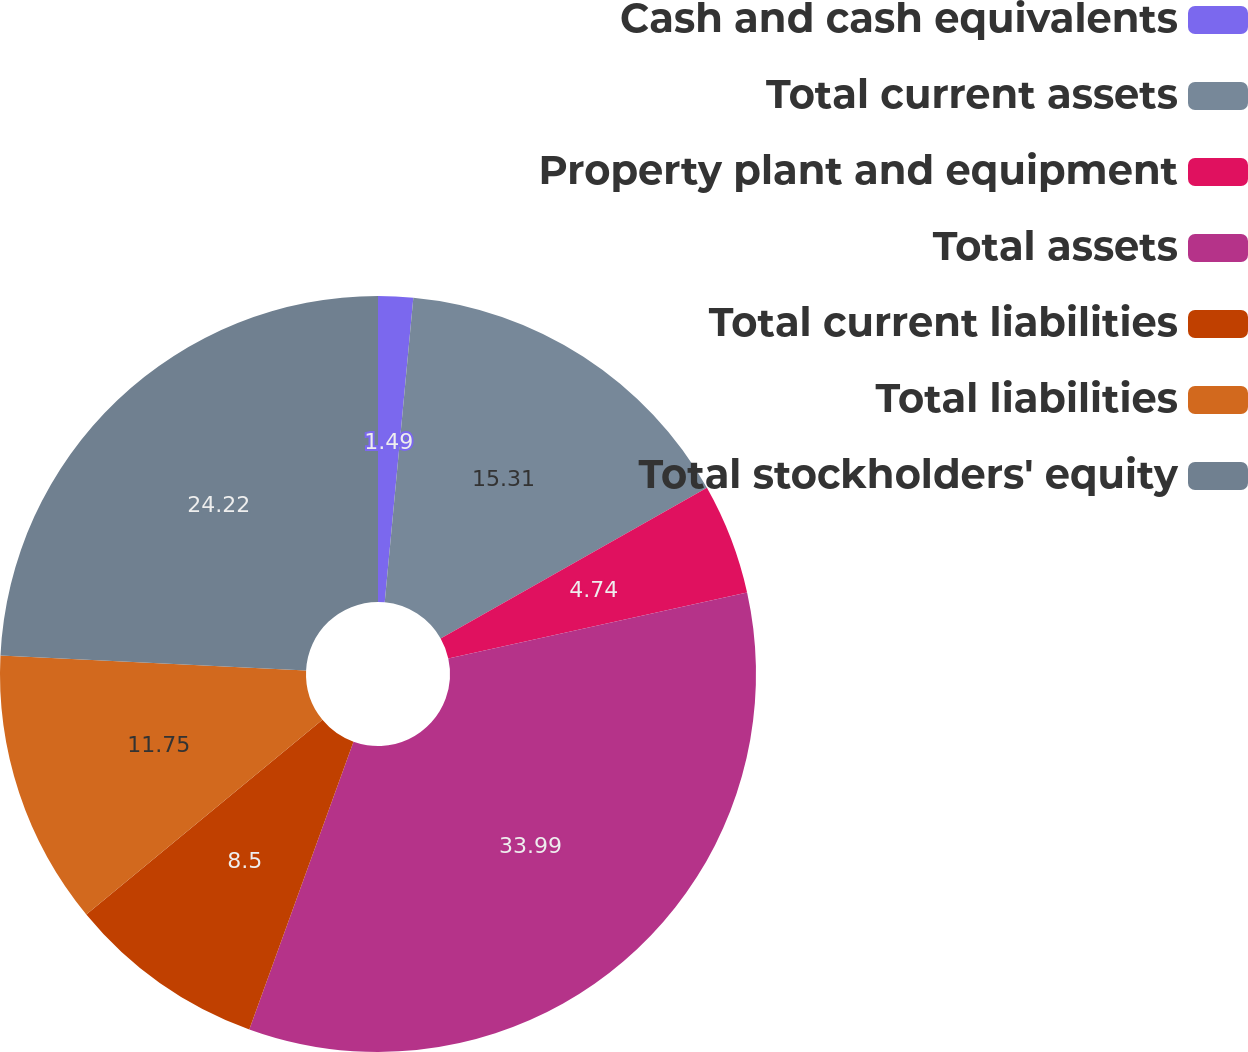Convert chart to OTSL. <chart><loc_0><loc_0><loc_500><loc_500><pie_chart><fcel>Cash and cash equivalents<fcel>Total current assets<fcel>Property plant and equipment<fcel>Total assets<fcel>Total current liabilities<fcel>Total liabilities<fcel>Total stockholders' equity<nl><fcel>1.49%<fcel>15.31%<fcel>4.74%<fcel>33.99%<fcel>8.5%<fcel>11.75%<fcel>24.22%<nl></chart> 